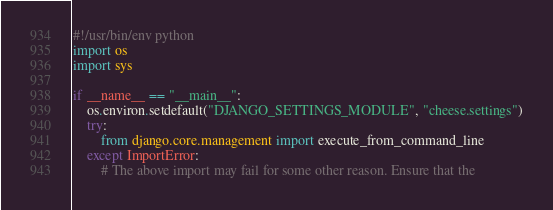Convert code to text. <code><loc_0><loc_0><loc_500><loc_500><_Python_>#!/usr/bin/env python
import os
import sys

if __name__ == "__main__":
    os.environ.setdefault("DJANGO_SETTINGS_MODULE", "cheese.settings")
    try:
        from django.core.management import execute_from_command_line
    except ImportError:
        # The above import may fail for some other reason. Ensure that the</code> 